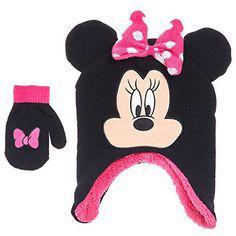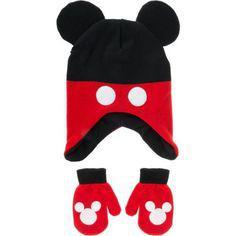The first image is the image on the left, the second image is the image on the right. Assess this claim about the two images: "There is one black and red hat with black mouse ears and two white dots on it beside two red mittens with white Mickey Mouse logos and black cuffs in each image,.". Correct or not? Answer yes or no. Yes. The first image is the image on the left, the second image is the image on the right. Given the left and right images, does the statement "One hat is black and red with two white button dots and one pair of red and black gloves has a white Mickey Mouse shape on each glove." hold true? Answer yes or no. Yes. 